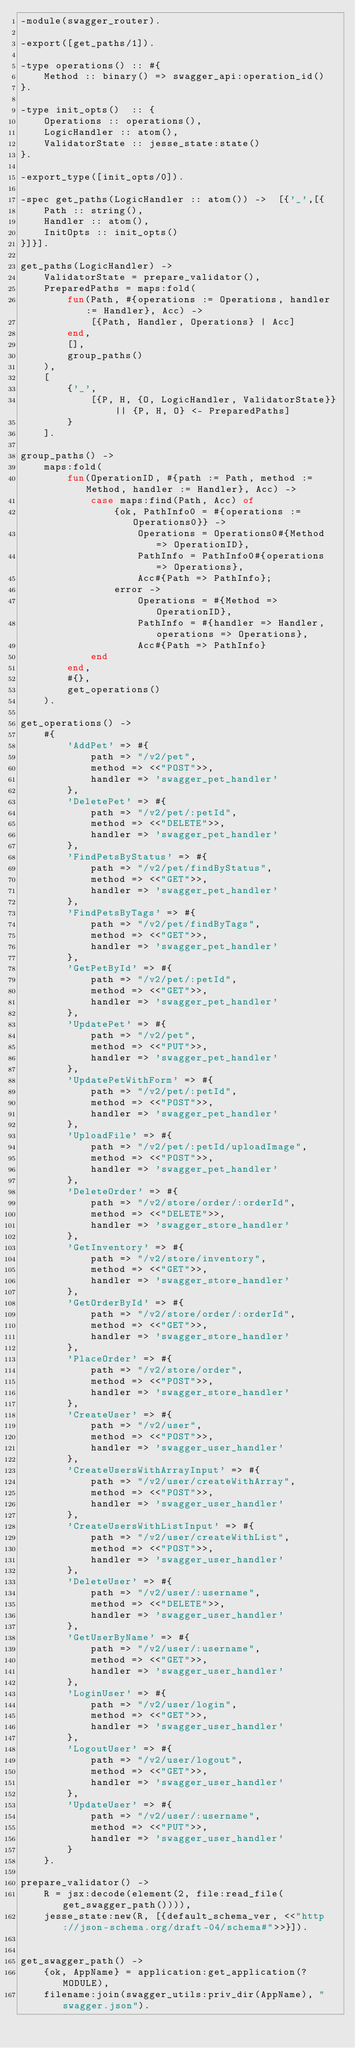<code> <loc_0><loc_0><loc_500><loc_500><_Erlang_>-module(swagger_router).

-export([get_paths/1]).

-type operations() :: #{
    Method :: binary() => swagger_api:operation_id()
}.

-type init_opts()  :: {
    Operations :: operations(),
    LogicHandler :: atom(),
    ValidatorState :: jesse_state:state()
}.

-export_type([init_opts/0]).

-spec get_paths(LogicHandler :: atom()) ->  [{'_',[{
    Path :: string(),
    Handler :: atom(),
    InitOpts :: init_opts()
}]}].

get_paths(LogicHandler) ->
    ValidatorState = prepare_validator(),
    PreparedPaths = maps:fold(
        fun(Path, #{operations := Operations, handler := Handler}, Acc) ->
            [{Path, Handler, Operations} | Acc]
        end,
        [],
        group_paths()
    ),
    [
        {'_',
            [{P, H, {O, LogicHandler, ValidatorState}} || {P, H, O} <- PreparedPaths]
        }
    ].

group_paths() ->
    maps:fold(
        fun(OperationID, #{path := Path, method := Method, handler := Handler}, Acc) ->
            case maps:find(Path, Acc) of
                {ok, PathInfo0 = #{operations := Operations0}} ->
                    Operations = Operations0#{Method => OperationID},
                    PathInfo = PathInfo0#{operations => Operations},
                    Acc#{Path => PathInfo};
                error ->
                    Operations = #{Method => OperationID},
                    PathInfo = #{handler => Handler, operations => Operations},
                    Acc#{Path => PathInfo}
            end
        end,
        #{},
        get_operations()
    ).

get_operations() ->
    #{ 
        'AddPet' => #{
            path => "/v2/pet",
            method => <<"POST">>,
            handler => 'swagger_pet_handler'
        },
        'DeletePet' => #{
            path => "/v2/pet/:petId",
            method => <<"DELETE">>,
            handler => 'swagger_pet_handler'
        },
        'FindPetsByStatus' => #{
            path => "/v2/pet/findByStatus",
            method => <<"GET">>,
            handler => 'swagger_pet_handler'
        },
        'FindPetsByTags' => #{
            path => "/v2/pet/findByTags",
            method => <<"GET">>,
            handler => 'swagger_pet_handler'
        },
        'GetPetById' => #{
            path => "/v2/pet/:petId",
            method => <<"GET">>,
            handler => 'swagger_pet_handler'
        },
        'UpdatePet' => #{
            path => "/v2/pet",
            method => <<"PUT">>,
            handler => 'swagger_pet_handler'
        },
        'UpdatePetWithForm' => #{
            path => "/v2/pet/:petId",
            method => <<"POST">>,
            handler => 'swagger_pet_handler'
        },
        'UploadFile' => #{
            path => "/v2/pet/:petId/uploadImage",
            method => <<"POST">>,
            handler => 'swagger_pet_handler'
        },
        'DeleteOrder' => #{
            path => "/v2/store/order/:orderId",
            method => <<"DELETE">>,
            handler => 'swagger_store_handler'
        },
        'GetInventory' => #{
            path => "/v2/store/inventory",
            method => <<"GET">>,
            handler => 'swagger_store_handler'
        },
        'GetOrderById' => #{
            path => "/v2/store/order/:orderId",
            method => <<"GET">>,
            handler => 'swagger_store_handler'
        },
        'PlaceOrder' => #{
            path => "/v2/store/order",
            method => <<"POST">>,
            handler => 'swagger_store_handler'
        },
        'CreateUser' => #{
            path => "/v2/user",
            method => <<"POST">>,
            handler => 'swagger_user_handler'
        },
        'CreateUsersWithArrayInput' => #{
            path => "/v2/user/createWithArray",
            method => <<"POST">>,
            handler => 'swagger_user_handler'
        },
        'CreateUsersWithListInput' => #{
            path => "/v2/user/createWithList",
            method => <<"POST">>,
            handler => 'swagger_user_handler'
        },
        'DeleteUser' => #{
            path => "/v2/user/:username",
            method => <<"DELETE">>,
            handler => 'swagger_user_handler'
        },
        'GetUserByName' => #{
            path => "/v2/user/:username",
            method => <<"GET">>,
            handler => 'swagger_user_handler'
        },
        'LoginUser' => #{
            path => "/v2/user/login",
            method => <<"GET">>,
            handler => 'swagger_user_handler'
        },
        'LogoutUser' => #{
            path => "/v2/user/logout",
            method => <<"GET">>,
            handler => 'swagger_user_handler'
        },
        'UpdateUser' => #{
            path => "/v2/user/:username",
            method => <<"PUT">>,
            handler => 'swagger_user_handler'
        }
    }.

prepare_validator() ->
    R = jsx:decode(element(2, file:read_file(get_swagger_path()))),
    jesse_state:new(R, [{default_schema_ver, <<"http://json-schema.org/draft-04/schema#">>}]).


get_swagger_path() ->
    {ok, AppName} = application:get_application(?MODULE),
    filename:join(swagger_utils:priv_dir(AppName), "swagger.json").


</code> 